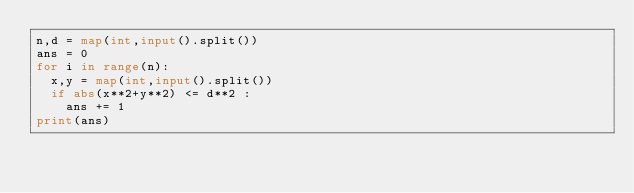Convert code to text. <code><loc_0><loc_0><loc_500><loc_500><_Python_>n,d = map(int,input().split())
ans = 0
for i in range(n):
  x,y = map(int,input().split())
  if abs(x**2+y**2) <= d**2 :
    ans += 1
print(ans)</code> 